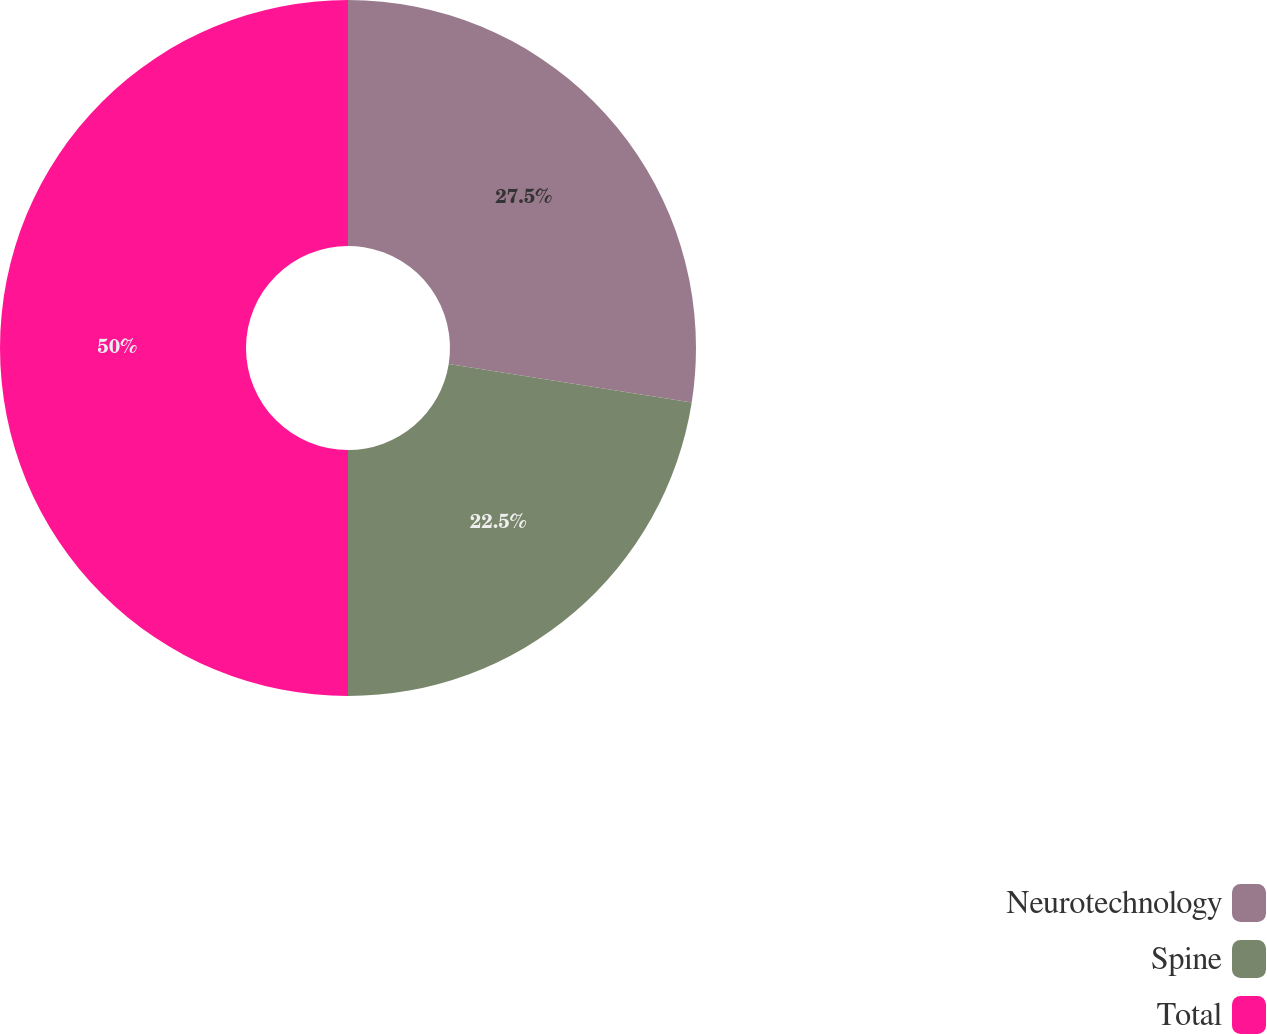<chart> <loc_0><loc_0><loc_500><loc_500><pie_chart><fcel>Neurotechnology<fcel>Spine<fcel>Total<nl><fcel>27.5%<fcel>22.5%<fcel>50.0%<nl></chart> 